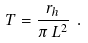<formula> <loc_0><loc_0><loc_500><loc_500>T = \frac { r _ { h } } { \pi \, L ^ { 2 } } \ .</formula> 